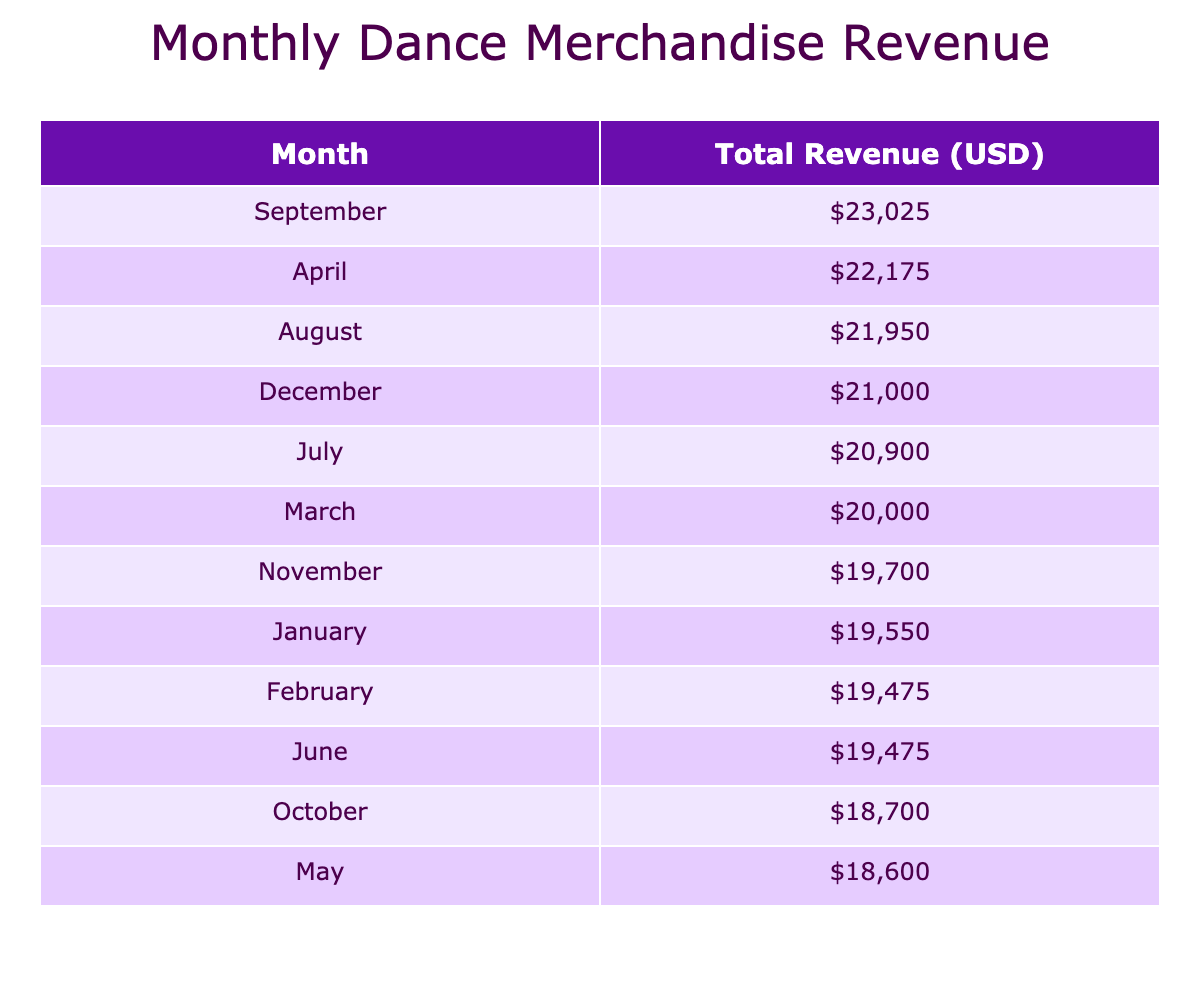What was the total revenue in December? In the table under the month of December, the total revenue is shown as 29,250 USD (sum of revenue from all categories).
Answer: 29,250 USD Which month had the highest total revenue? By examining the total revenues listed for each month, it appears that August had the highest total revenue of 32,000 USD.
Answer: August How much did accessories generate in revenue for the month of March? In March, the accessories revenue totals to 4,350 USD (sum of revenue from Leg Warmers and Hair Bands).
Answer: 4,350 USD Was the revenue for Apparel in November higher than in April? The Apparel revenue for November is 7,925 USD, whereas for April, it is 8,500 USD. Since 7,925 is less than 8,500, the statement is false.
Answer: No What was the average revenue per month across all months for Shoes? The total revenue from Shoes across all months is calculated as 45,875 USD, and since there are 12 months, dividing gives an average of 3,823.75 USD.
Answer: 3,823.75 USD During which month did the sales of Dance T-shirts see the most units sold? The highest units sold for Dance T-shirts were in September with 180 units.
Answer: September How much more revenue did Ballet Shoes generate in July compared to February? In July, Ballet Shoes generated 4,750 USD, while in February, they generated 5,000 USD. Thus, the difference is 5,000 - 4,750 = 250, indicating July had less revenue.
Answer: 250 USD less What is the total revenue for Accessories for the entire year? Adding the revenues for Accessories from each month yields a total of 37,500 USD for the entire year (detailed as: January 4,250 + February 3,850 + ... + December 3,900).
Answer: 37,500 USD Overall, how much did the sales of Shoes contribute to the total revenue in the year? By totaling all the revenue from Shoes, which amounts to 45,875 USD for the year, we can determine that they contributed significantly to overall sales.
Answer: 45,875 USD 